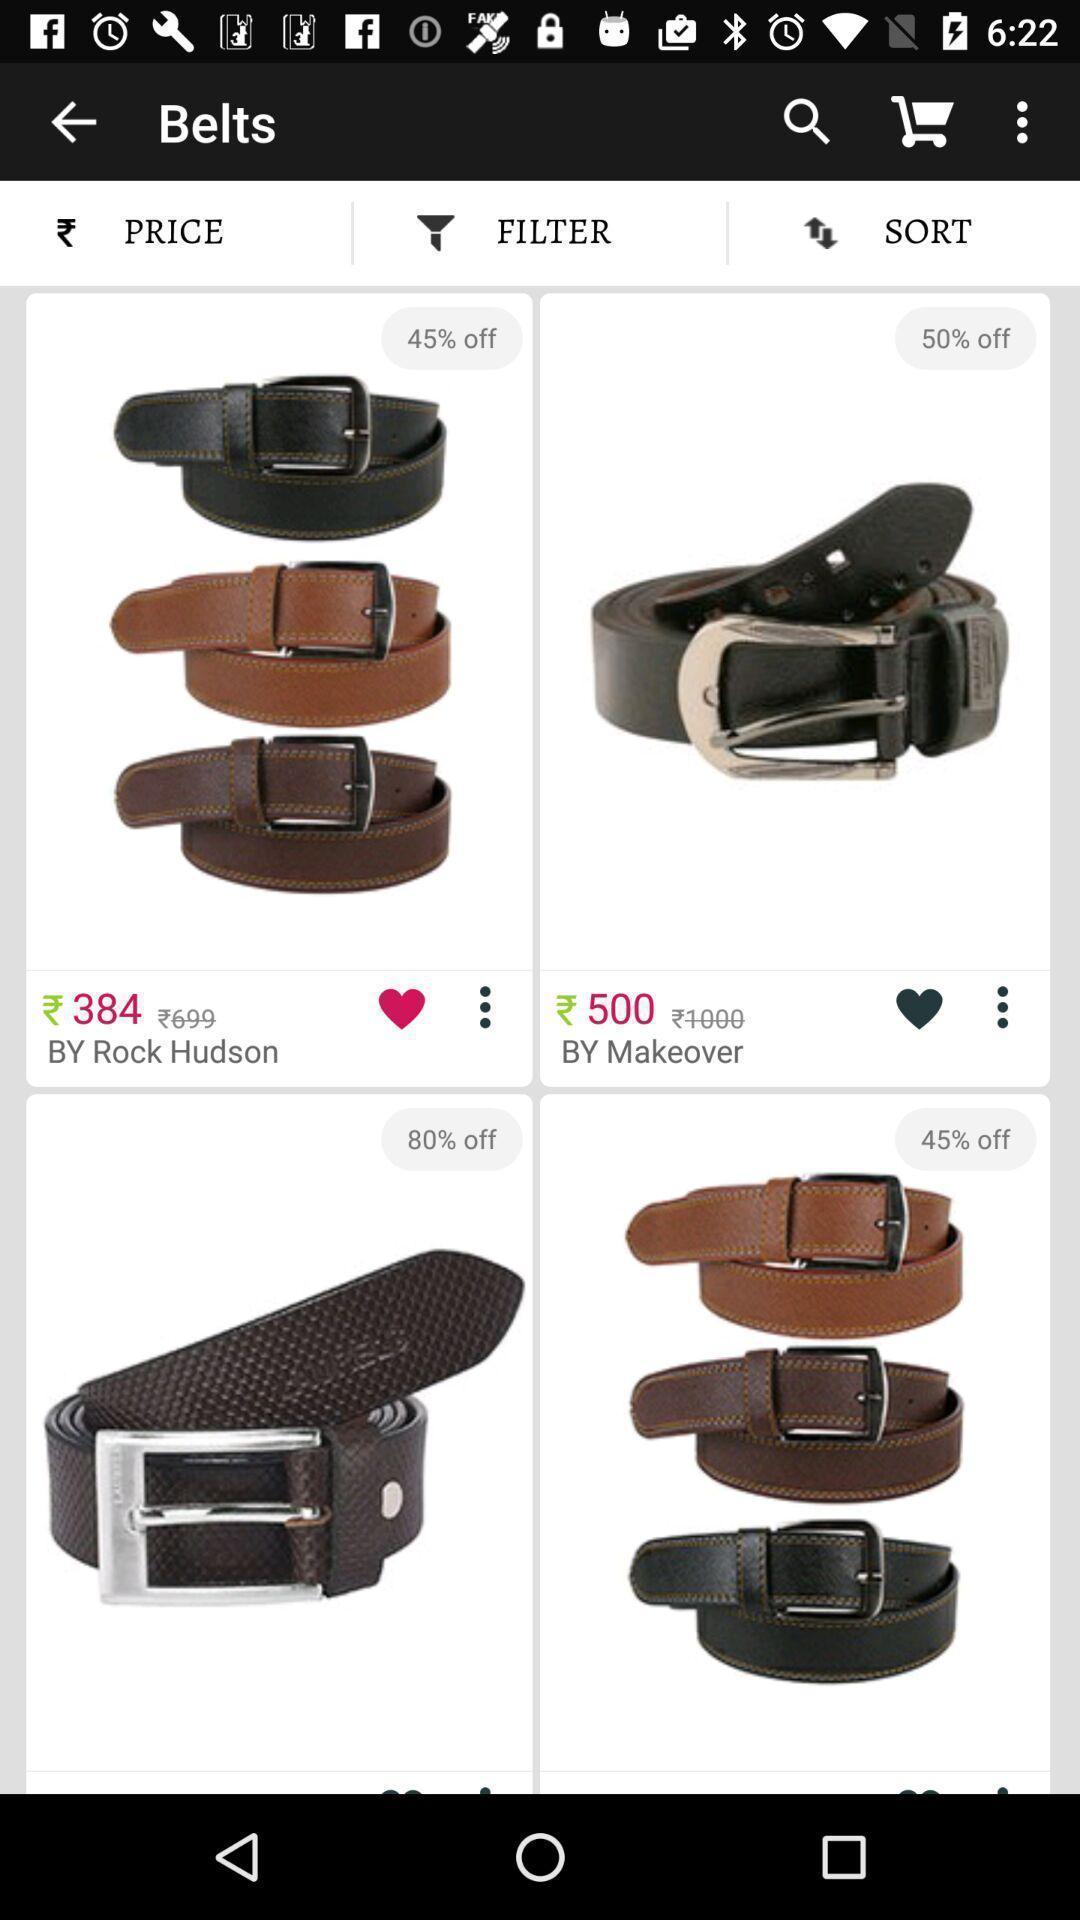Describe the content in this image. Screen displaying multiple product images with price. 